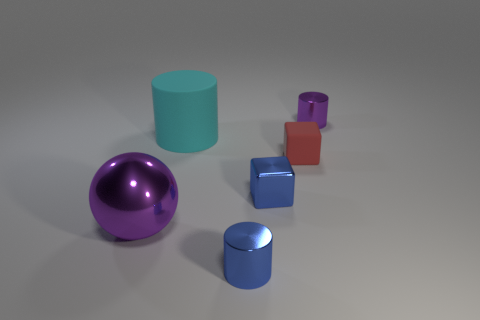Subtract all purple cylinders. How many cylinders are left? 2 Subtract all cyan balls. Subtract all brown blocks. How many balls are left? 1 Subtract all gray blocks. How many brown spheres are left? 0 Subtract all tiny things. Subtract all matte things. How many objects are left? 0 Add 5 purple shiny cylinders. How many purple shiny cylinders are left? 6 Add 1 yellow metallic spheres. How many yellow metallic spheres exist? 1 Add 1 green shiny cylinders. How many objects exist? 7 Subtract all blue cubes. How many cubes are left? 1 Subtract 0 yellow cubes. How many objects are left? 6 Subtract all blocks. How many objects are left? 4 